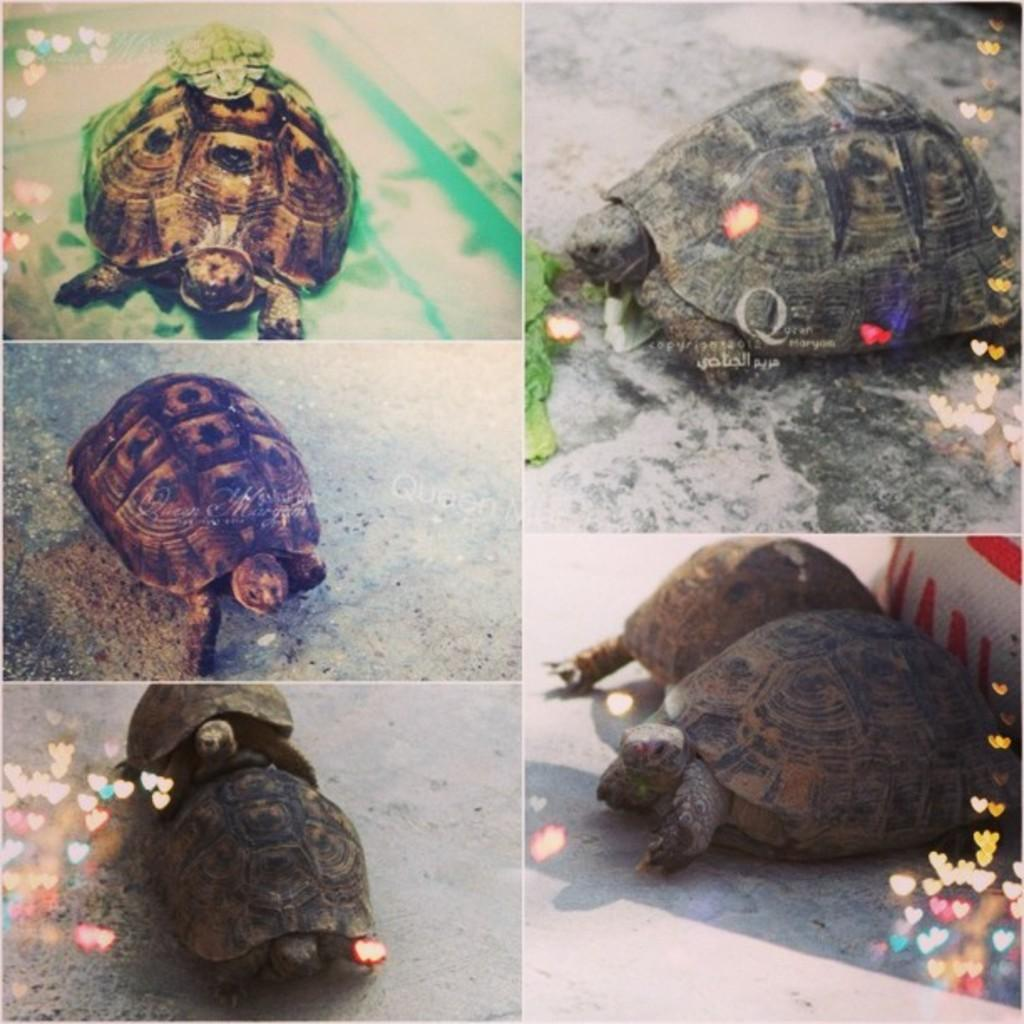What type of artwork is depicted in the image? The image is a collage. What animals can be seen in the collage? There are turtles in the image. What color is present in the image? There is a green color thing in the image. What shapes or symbols are present in the image? There are colorful hearts in the image. What type of flower is depicted in the image? There is no flower present in the image; it features a collage with turtles, a green color thing, and colorful hearts. 